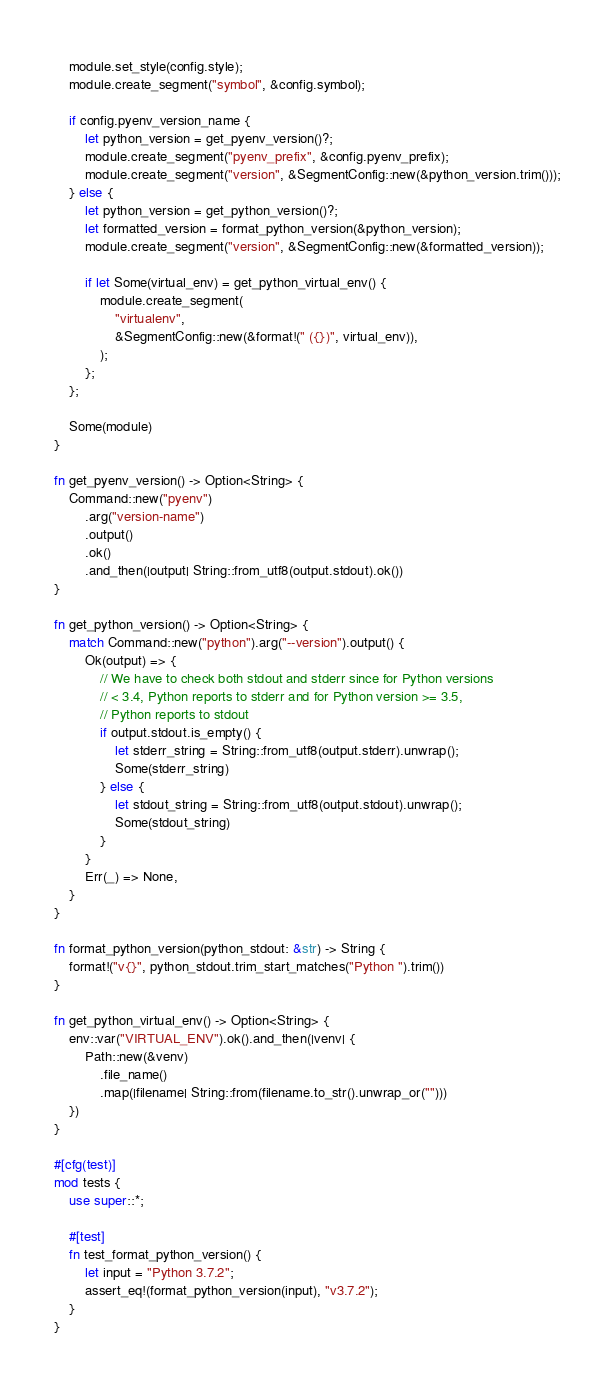Convert code to text. <code><loc_0><loc_0><loc_500><loc_500><_Rust_>
    module.set_style(config.style);
    module.create_segment("symbol", &config.symbol);

    if config.pyenv_version_name {
        let python_version = get_pyenv_version()?;
        module.create_segment("pyenv_prefix", &config.pyenv_prefix);
        module.create_segment("version", &SegmentConfig::new(&python_version.trim()));
    } else {
        let python_version = get_python_version()?;
        let formatted_version = format_python_version(&python_version);
        module.create_segment("version", &SegmentConfig::new(&formatted_version));

        if let Some(virtual_env) = get_python_virtual_env() {
            module.create_segment(
                "virtualenv",
                &SegmentConfig::new(&format!(" ({})", virtual_env)),
            );
        };
    };

    Some(module)
}

fn get_pyenv_version() -> Option<String> {
    Command::new("pyenv")
        .arg("version-name")
        .output()
        .ok()
        .and_then(|output| String::from_utf8(output.stdout).ok())
}

fn get_python_version() -> Option<String> {
    match Command::new("python").arg("--version").output() {
        Ok(output) => {
            // We have to check both stdout and stderr since for Python versions
            // < 3.4, Python reports to stderr and for Python version >= 3.5,
            // Python reports to stdout
            if output.stdout.is_empty() {
                let stderr_string = String::from_utf8(output.stderr).unwrap();
                Some(stderr_string)
            } else {
                let stdout_string = String::from_utf8(output.stdout).unwrap();
                Some(stdout_string)
            }
        }
        Err(_) => None,
    }
}

fn format_python_version(python_stdout: &str) -> String {
    format!("v{}", python_stdout.trim_start_matches("Python ").trim())
}

fn get_python_virtual_env() -> Option<String> {
    env::var("VIRTUAL_ENV").ok().and_then(|venv| {
        Path::new(&venv)
            .file_name()
            .map(|filename| String::from(filename.to_str().unwrap_or("")))
    })
}

#[cfg(test)]
mod tests {
    use super::*;

    #[test]
    fn test_format_python_version() {
        let input = "Python 3.7.2";
        assert_eq!(format_python_version(input), "v3.7.2");
    }
}
</code> 